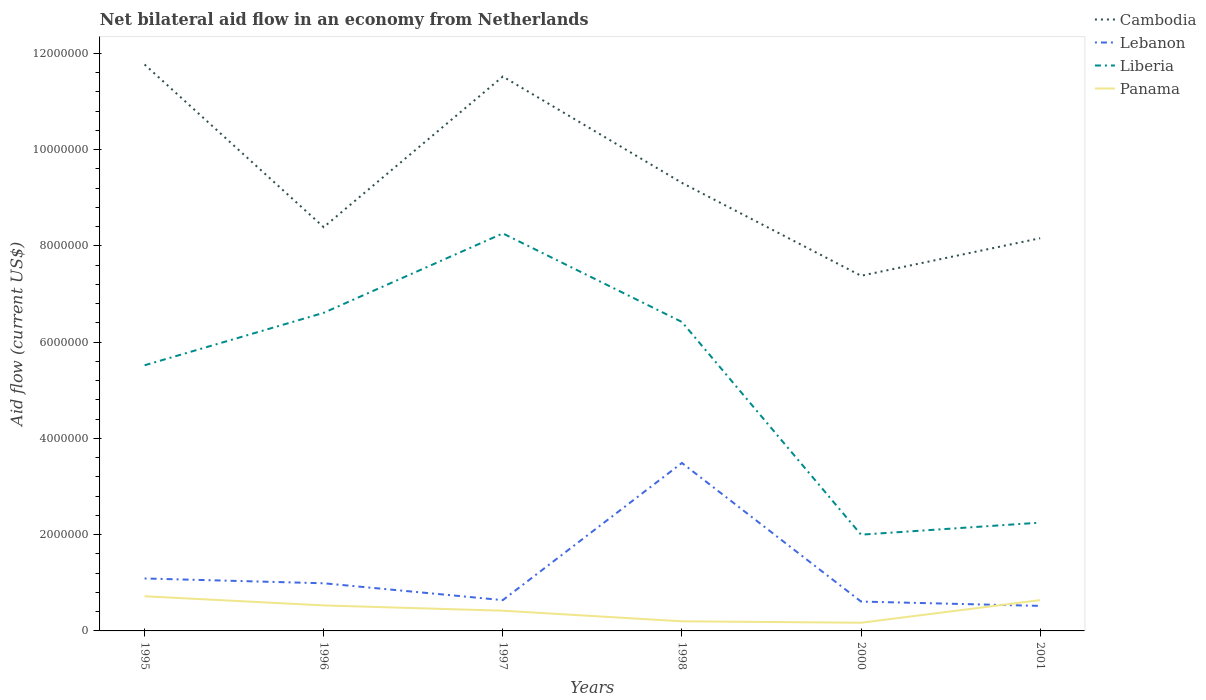How many different coloured lines are there?
Your answer should be very brief. 4. Is the number of lines equal to the number of legend labels?
Your response must be concise. Yes. Across all years, what is the maximum net bilateral aid flow in Cambodia?
Make the answer very short. 7.38e+06. In which year was the net bilateral aid flow in Panama maximum?
Your answer should be very brief. 2000. What is the total net bilateral aid flow in Cambodia in the graph?
Offer a terse response. 4.14e+06. How many years are there in the graph?
Offer a terse response. 6. Does the graph contain grids?
Offer a terse response. No. How many legend labels are there?
Your answer should be very brief. 4. What is the title of the graph?
Your answer should be compact. Net bilateral aid flow in an economy from Netherlands. Does "Maldives" appear as one of the legend labels in the graph?
Make the answer very short. No. What is the Aid flow (current US$) in Cambodia in 1995?
Your answer should be very brief. 1.18e+07. What is the Aid flow (current US$) of Lebanon in 1995?
Provide a succinct answer. 1.09e+06. What is the Aid flow (current US$) in Liberia in 1995?
Your response must be concise. 5.52e+06. What is the Aid flow (current US$) in Panama in 1995?
Keep it short and to the point. 7.20e+05. What is the Aid flow (current US$) in Cambodia in 1996?
Give a very brief answer. 8.39e+06. What is the Aid flow (current US$) of Lebanon in 1996?
Your response must be concise. 9.90e+05. What is the Aid flow (current US$) of Liberia in 1996?
Offer a very short reply. 6.61e+06. What is the Aid flow (current US$) of Panama in 1996?
Ensure brevity in your answer.  5.30e+05. What is the Aid flow (current US$) of Cambodia in 1997?
Keep it short and to the point. 1.15e+07. What is the Aid flow (current US$) in Lebanon in 1997?
Give a very brief answer. 6.40e+05. What is the Aid flow (current US$) of Liberia in 1997?
Your response must be concise. 8.26e+06. What is the Aid flow (current US$) of Panama in 1997?
Offer a very short reply. 4.20e+05. What is the Aid flow (current US$) of Cambodia in 1998?
Ensure brevity in your answer.  9.31e+06. What is the Aid flow (current US$) of Lebanon in 1998?
Your answer should be very brief. 3.49e+06. What is the Aid flow (current US$) in Liberia in 1998?
Give a very brief answer. 6.42e+06. What is the Aid flow (current US$) of Panama in 1998?
Your response must be concise. 2.00e+05. What is the Aid flow (current US$) in Cambodia in 2000?
Provide a succinct answer. 7.38e+06. What is the Aid flow (current US$) of Lebanon in 2000?
Your answer should be very brief. 6.10e+05. What is the Aid flow (current US$) of Liberia in 2000?
Ensure brevity in your answer.  2.00e+06. What is the Aid flow (current US$) in Cambodia in 2001?
Your answer should be compact. 8.16e+06. What is the Aid flow (current US$) of Lebanon in 2001?
Make the answer very short. 5.20e+05. What is the Aid flow (current US$) in Liberia in 2001?
Offer a terse response. 2.25e+06. What is the Aid flow (current US$) in Panama in 2001?
Provide a succinct answer. 6.40e+05. Across all years, what is the maximum Aid flow (current US$) of Cambodia?
Provide a succinct answer. 1.18e+07. Across all years, what is the maximum Aid flow (current US$) of Lebanon?
Your response must be concise. 3.49e+06. Across all years, what is the maximum Aid flow (current US$) of Liberia?
Ensure brevity in your answer.  8.26e+06. Across all years, what is the maximum Aid flow (current US$) of Panama?
Provide a succinct answer. 7.20e+05. Across all years, what is the minimum Aid flow (current US$) of Cambodia?
Your answer should be very brief. 7.38e+06. Across all years, what is the minimum Aid flow (current US$) in Lebanon?
Ensure brevity in your answer.  5.20e+05. What is the total Aid flow (current US$) of Cambodia in the graph?
Your response must be concise. 5.65e+07. What is the total Aid flow (current US$) in Lebanon in the graph?
Provide a succinct answer. 7.34e+06. What is the total Aid flow (current US$) of Liberia in the graph?
Offer a very short reply. 3.11e+07. What is the total Aid flow (current US$) of Panama in the graph?
Offer a very short reply. 2.68e+06. What is the difference between the Aid flow (current US$) of Cambodia in 1995 and that in 1996?
Ensure brevity in your answer.  3.38e+06. What is the difference between the Aid flow (current US$) in Lebanon in 1995 and that in 1996?
Give a very brief answer. 1.00e+05. What is the difference between the Aid flow (current US$) of Liberia in 1995 and that in 1996?
Your response must be concise. -1.09e+06. What is the difference between the Aid flow (current US$) of Cambodia in 1995 and that in 1997?
Offer a very short reply. 2.50e+05. What is the difference between the Aid flow (current US$) in Lebanon in 1995 and that in 1997?
Your response must be concise. 4.50e+05. What is the difference between the Aid flow (current US$) of Liberia in 1995 and that in 1997?
Offer a very short reply. -2.74e+06. What is the difference between the Aid flow (current US$) in Cambodia in 1995 and that in 1998?
Provide a short and direct response. 2.46e+06. What is the difference between the Aid flow (current US$) in Lebanon in 1995 and that in 1998?
Your response must be concise. -2.40e+06. What is the difference between the Aid flow (current US$) of Liberia in 1995 and that in 1998?
Ensure brevity in your answer.  -9.00e+05. What is the difference between the Aid flow (current US$) of Panama in 1995 and that in 1998?
Offer a very short reply. 5.20e+05. What is the difference between the Aid flow (current US$) of Cambodia in 1995 and that in 2000?
Offer a very short reply. 4.39e+06. What is the difference between the Aid flow (current US$) in Liberia in 1995 and that in 2000?
Your answer should be very brief. 3.52e+06. What is the difference between the Aid flow (current US$) of Cambodia in 1995 and that in 2001?
Give a very brief answer. 3.61e+06. What is the difference between the Aid flow (current US$) of Lebanon in 1995 and that in 2001?
Provide a short and direct response. 5.70e+05. What is the difference between the Aid flow (current US$) in Liberia in 1995 and that in 2001?
Offer a very short reply. 3.27e+06. What is the difference between the Aid flow (current US$) of Cambodia in 1996 and that in 1997?
Give a very brief answer. -3.13e+06. What is the difference between the Aid flow (current US$) in Liberia in 1996 and that in 1997?
Offer a terse response. -1.65e+06. What is the difference between the Aid flow (current US$) in Cambodia in 1996 and that in 1998?
Make the answer very short. -9.20e+05. What is the difference between the Aid flow (current US$) in Lebanon in 1996 and that in 1998?
Give a very brief answer. -2.50e+06. What is the difference between the Aid flow (current US$) in Liberia in 1996 and that in 1998?
Give a very brief answer. 1.90e+05. What is the difference between the Aid flow (current US$) in Cambodia in 1996 and that in 2000?
Provide a short and direct response. 1.01e+06. What is the difference between the Aid flow (current US$) of Liberia in 1996 and that in 2000?
Your response must be concise. 4.61e+06. What is the difference between the Aid flow (current US$) in Panama in 1996 and that in 2000?
Your answer should be compact. 3.60e+05. What is the difference between the Aid flow (current US$) of Liberia in 1996 and that in 2001?
Your answer should be very brief. 4.36e+06. What is the difference between the Aid flow (current US$) in Cambodia in 1997 and that in 1998?
Your answer should be very brief. 2.21e+06. What is the difference between the Aid flow (current US$) in Lebanon in 1997 and that in 1998?
Ensure brevity in your answer.  -2.85e+06. What is the difference between the Aid flow (current US$) in Liberia in 1997 and that in 1998?
Provide a short and direct response. 1.84e+06. What is the difference between the Aid flow (current US$) in Panama in 1997 and that in 1998?
Keep it short and to the point. 2.20e+05. What is the difference between the Aid flow (current US$) of Cambodia in 1997 and that in 2000?
Your response must be concise. 4.14e+06. What is the difference between the Aid flow (current US$) in Lebanon in 1997 and that in 2000?
Your response must be concise. 3.00e+04. What is the difference between the Aid flow (current US$) of Liberia in 1997 and that in 2000?
Keep it short and to the point. 6.26e+06. What is the difference between the Aid flow (current US$) in Panama in 1997 and that in 2000?
Offer a very short reply. 2.50e+05. What is the difference between the Aid flow (current US$) in Cambodia in 1997 and that in 2001?
Your answer should be compact. 3.36e+06. What is the difference between the Aid flow (current US$) of Liberia in 1997 and that in 2001?
Provide a succinct answer. 6.01e+06. What is the difference between the Aid flow (current US$) of Panama in 1997 and that in 2001?
Your response must be concise. -2.20e+05. What is the difference between the Aid flow (current US$) of Cambodia in 1998 and that in 2000?
Your response must be concise. 1.93e+06. What is the difference between the Aid flow (current US$) of Lebanon in 1998 and that in 2000?
Your response must be concise. 2.88e+06. What is the difference between the Aid flow (current US$) of Liberia in 1998 and that in 2000?
Keep it short and to the point. 4.42e+06. What is the difference between the Aid flow (current US$) of Cambodia in 1998 and that in 2001?
Make the answer very short. 1.15e+06. What is the difference between the Aid flow (current US$) of Lebanon in 1998 and that in 2001?
Keep it short and to the point. 2.97e+06. What is the difference between the Aid flow (current US$) in Liberia in 1998 and that in 2001?
Offer a terse response. 4.17e+06. What is the difference between the Aid flow (current US$) in Panama in 1998 and that in 2001?
Give a very brief answer. -4.40e+05. What is the difference between the Aid flow (current US$) of Cambodia in 2000 and that in 2001?
Your response must be concise. -7.80e+05. What is the difference between the Aid flow (current US$) in Lebanon in 2000 and that in 2001?
Your response must be concise. 9.00e+04. What is the difference between the Aid flow (current US$) of Liberia in 2000 and that in 2001?
Ensure brevity in your answer.  -2.50e+05. What is the difference between the Aid flow (current US$) of Panama in 2000 and that in 2001?
Your answer should be very brief. -4.70e+05. What is the difference between the Aid flow (current US$) in Cambodia in 1995 and the Aid flow (current US$) in Lebanon in 1996?
Make the answer very short. 1.08e+07. What is the difference between the Aid flow (current US$) in Cambodia in 1995 and the Aid flow (current US$) in Liberia in 1996?
Provide a short and direct response. 5.16e+06. What is the difference between the Aid flow (current US$) in Cambodia in 1995 and the Aid flow (current US$) in Panama in 1996?
Provide a short and direct response. 1.12e+07. What is the difference between the Aid flow (current US$) of Lebanon in 1995 and the Aid flow (current US$) of Liberia in 1996?
Offer a terse response. -5.52e+06. What is the difference between the Aid flow (current US$) of Lebanon in 1995 and the Aid flow (current US$) of Panama in 1996?
Your answer should be compact. 5.60e+05. What is the difference between the Aid flow (current US$) in Liberia in 1995 and the Aid flow (current US$) in Panama in 1996?
Your answer should be compact. 4.99e+06. What is the difference between the Aid flow (current US$) of Cambodia in 1995 and the Aid flow (current US$) of Lebanon in 1997?
Your response must be concise. 1.11e+07. What is the difference between the Aid flow (current US$) in Cambodia in 1995 and the Aid flow (current US$) in Liberia in 1997?
Provide a succinct answer. 3.51e+06. What is the difference between the Aid flow (current US$) in Cambodia in 1995 and the Aid flow (current US$) in Panama in 1997?
Your response must be concise. 1.14e+07. What is the difference between the Aid flow (current US$) in Lebanon in 1995 and the Aid flow (current US$) in Liberia in 1997?
Keep it short and to the point. -7.17e+06. What is the difference between the Aid flow (current US$) in Lebanon in 1995 and the Aid flow (current US$) in Panama in 1997?
Give a very brief answer. 6.70e+05. What is the difference between the Aid flow (current US$) in Liberia in 1995 and the Aid flow (current US$) in Panama in 1997?
Your answer should be compact. 5.10e+06. What is the difference between the Aid flow (current US$) in Cambodia in 1995 and the Aid flow (current US$) in Lebanon in 1998?
Your response must be concise. 8.28e+06. What is the difference between the Aid flow (current US$) of Cambodia in 1995 and the Aid flow (current US$) of Liberia in 1998?
Offer a terse response. 5.35e+06. What is the difference between the Aid flow (current US$) in Cambodia in 1995 and the Aid flow (current US$) in Panama in 1998?
Give a very brief answer. 1.16e+07. What is the difference between the Aid flow (current US$) of Lebanon in 1995 and the Aid flow (current US$) of Liberia in 1998?
Give a very brief answer. -5.33e+06. What is the difference between the Aid flow (current US$) in Lebanon in 1995 and the Aid flow (current US$) in Panama in 1998?
Provide a succinct answer. 8.90e+05. What is the difference between the Aid flow (current US$) of Liberia in 1995 and the Aid flow (current US$) of Panama in 1998?
Make the answer very short. 5.32e+06. What is the difference between the Aid flow (current US$) in Cambodia in 1995 and the Aid flow (current US$) in Lebanon in 2000?
Make the answer very short. 1.12e+07. What is the difference between the Aid flow (current US$) of Cambodia in 1995 and the Aid flow (current US$) of Liberia in 2000?
Keep it short and to the point. 9.77e+06. What is the difference between the Aid flow (current US$) of Cambodia in 1995 and the Aid flow (current US$) of Panama in 2000?
Offer a terse response. 1.16e+07. What is the difference between the Aid flow (current US$) in Lebanon in 1995 and the Aid flow (current US$) in Liberia in 2000?
Keep it short and to the point. -9.10e+05. What is the difference between the Aid flow (current US$) in Lebanon in 1995 and the Aid flow (current US$) in Panama in 2000?
Your answer should be compact. 9.20e+05. What is the difference between the Aid flow (current US$) of Liberia in 1995 and the Aid flow (current US$) of Panama in 2000?
Your answer should be compact. 5.35e+06. What is the difference between the Aid flow (current US$) of Cambodia in 1995 and the Aid flow (current US$) of Lebanon in 2001?
Offer a very short reply. 1.12e+07. What is the difference between the Aid flow (current US$) in Cambodia in 1995 and the Aid flow (current US$) in Liberia in 2001?
Give a very brief answer. 9.52e+06. What is the difference between the Aid flow (current US$) in Cambodia in 1995 and the Aid flow (current US$) in Panama in 2001?
Ensure brevity in your answer.  1.11e+07. What is the difference between the Aid flow (current US$) in Lebanon in 1995 and the Aid flow (current US$) in Liberia in 2001?
Offer a very short reply. -1.16e+06. What is the difference between the Aid flow (current US$) in Lebanon in 1995 and the Aid flow (current US$) in Panama in 2001?
Make the answer very short. 4.50e+05. What is the difference between the Aid flow (current US$) of Liberia in 1995 and the Aid flow (current US$) of Panama in 2001?
Your answer should be very brief. 4.88e+06. What is the difference between the Aid flow (current US$) of Cambodia in 1996 and the Aid flow (current US$) of Lebanon in 1997?
Give a very brief answer. 7.75e+06. What is the difference between the Aid flow (current US$) in Cambodia in 1996 and the Aid flow (current US$) in Panama in 1997?
Provide a succinct answer. 7.97e+06. What is the difference between the Aid flow (current US$) in Lebanon in 1996 and the Aid flow (current US$) in Liberia in 1997?
Your response must be concise. -7.27e+06. What is the difference between the Aid flow (current US$) of Lebanon in 1996 and the Aid flow (current US$) of Panama in 1997?
Offer a very short reply. 5.70e+05. What is the difference between the Aid flow (current US$) of Liberia in 1996 and the Aid flow (current US$) of Panama in 1997?
Keep it short and to the point. 6.19e+06. What is the difference between the Aid flow (current US$) of Cambodia in 1996 and the Aid flow (current US$) of Lebanon in 1998?
Keep it short and to the point. 4.90e+06. What is the difference between the Aid flow (current US$) of Cambodia in 1996 and the Aid flow (current US$) of Liberia in 1998?
Provide a short and direct response. 1.97e+06. What is the difference between the Aid flow (current US$) of Cambodia in 1996 and the Aid flow (current US$) of Panama in 1998?
Your response must be concise. 8.19e+06. What is the difference between the Aid flow (current US$) of Lebanon in 1996 and the Aid flow (current US$) of Liberia in 1998?
Your answer should be compact. -5.43e+06. What is the difference between the Aid flow (current US$) of Lebanon in 1996 and the Aid flow (current US$) of Panama in 1998?
Keep it short and to the point. 7.90e+05. What is the difference between the Aid flow (current US$) in Liberia in 1996 and the Aid flow (current US$) in Panama in 1998?
Give a very brief answer. 6.41e+06. What is the difference between the Aid flow (current US$) in Cambodia in 1996 and the Aid flow (current US$) in Lebanon in 2000?
Give a very brief answer. 7.78e+06. What is the difference between the Aid flow (current US$) in Cambodia in 1996 and the Aid flow (current US$) in Liberia in 2000?
Ensure brevity in your answer.  6.39e+06. What is the difference between the Aid flow (current US$) in Cambodia in 1996 and the Aid flow (current US$) in Panama in 2000?
Your answer should be very brief. 8.22e+06. What is the difference between the Aid flow (current US$) in Lebanon in 1996 and the Aid flow (current US$) in Liberia in 2000?
Offer a very short reply. -1.01e+06. What is the difference between the Aid flow (current US$) in Lebanon in 1996 and the Aid flow (current US$) in Panama in 2000?
Your answer should be very brief. 8.20e+05. What is the difference between the Aid flow (current US$) of Liberia in 1996 and the Aid flow (current US$) of Panama in 2000?
Offer a very short reply. 6.44e+06. What is the difference between the Aid flow (current US$) in Cambodia in 1996 and the Aid flow (current US$) in Lebanon in 2001?
Your response must be concise. 7.87e+06. What is the difference between the Aid flow (current US$) in Cambodia in 1996 and the Aid flow (current US$) in Liberia in 2001?
Provide a succinct answer. 6.14e+06. What is the difference between the Aid flow (current US$) of Cambodia in 1996 and the Aid flow (current US$) of Panama in 2001?
Your answer should be very brief. 7.75e+06. What is the difference between the Aid flow (current US$) of Lebanon in 1996 and the Aid flow (current US$) of Liberia in 2001?
Provide a short and direct response. -1.26e+06. What is the difference between the Aid flow (current US$) of Liberia in 1996 and the Aid flow (current US$) of Panama in 2001?
Keep it short and to the point. 5.97e+06. What is the difference between the Aid flow (current US$) in Cambodia in 1997 and the Aid flow (current US$) in Lebanon in 1998?
Provide a short and direct response. 8.03e+06. What is the difference between the Aid flow (current US$) in Cambodia in 1997 and the Aid flow (current US$) in Liberia in 1998?
Provide a succinct answer. 5.10e+06. What is the difference between the Aid flow (current US$) of Cambodia in 1997 and the Aid flow (current US$) of Panama in 1998?
Give a very brief answer. 1.13e+07. What is the difference between the Aid flow (current US$) in Lebanon in 1997 and the Aid flow (current US$) in Liberia in 1998?
Keep it short and to the point. -5.78e+06. What is the difference between the Aid flow (current US$) of Liberia in 1997 and the Aid flow (current US$) of Panama in 1998?
Your answer should be very brief. 8.06e+06. What is the difference between the Aid flow (current US$) in Cambodia in 1997 and the Aid flow (current US$) in Lebanon in 2000?
Keep it short and to the point. 1.09e+07. What is the difference between the Aid flow (current US$) in Cambodia in 1997 and the Aid flow (current US$) in Liberia in 2000?
Keep it short and to the point. 9.52e+06. What is the difference between the Aid flow (current US$) in Cambodia in 1997 and the Aid flow (current US$) in Panama in 2000?
Provide a succinct answer. 1.14e+07. What is the difference between the Aid flow (current US$) in Lebanon in 1997 and the Aid flow (current US$) in Liberia in 2000?
Your answer should be compact. -1.36e+06. What is the difference between the Aid flow (current US$) of Liberia in 1997 and the Aid flow (current US$) of Panama in 2000?
Make the answer very short. 8.09e+06. What is the difference between the Aid flow (current US$) in Cambodia in 1997 and the Aid flow (current US$) in Lebanon in 2001?
Give a very brief answer. 1.10e+07. What is the difference between the Aid flow (current US$) of Cambodia in 1997 and the Aid flow (current US$) of Liberia in 2001?
Your answer should be very brief. 9.27e+06. What is the difference between the Aid flow (current US$) of Cambodia in 1997 and the Aid flow (current US$) of Panama in 2001?
Make the answer very short. 1.09e+07. What is the difference between the Aid flow (current US$) of Lebanon in 1997 and the Aid flow (current US$) of Liberia in 2001?
Give a very brief answer. -1.61e+06. What is the difference between the Aid flow (current US$) in Liberia in 1997 and the Aid flow (current US$) in Panama in 2001?
Provide a short and direct response. 7.62e+06. What is the difference between the Aid flow (current US$) of Cambodia in 1998 and the Aid flow (current US$) of Lebanon in 2000?
Ensure brevity in your answer.  8.70e+06. What is the difference between the Aid flow (current US$) in Cambodia in 1998 and the Aid flow (current US$) in Liberia in 2000?
Offer a terse response. 7.31e+06. What is the difference between the Aid flow (current US$) in Cambodia in 1998 and the Aid flow (current US$) in Panama in 2000?
Provide a succinct answer. 9.14e+06. What is the difference between the Aid flow (current US$) of Lebanon in 1998 and the Aid flow (current US$) of Liberia in 2000?
Provide a succinct answer. 1.49e+06. What is the difference between the Aid flow (current US$) in Lebanon in 1998 and the Aid flow (current US$) in Panama in 2000?
Your response must be concise. 3.32e+06. What is the difference between the Aid flow (current US$) in Liberia in 1998 and the Aid flow (current US$) in Panama in 2000?
Provide a short and direct response. 6.25e+06. What is the difference between the Aid flow (current US$) in Cambodia in 1998 and the Aid flow (current US$) in Lebanon in 2001?
Provide a succinct answer. 8.79e+06. What is the difference between the Aid flow (current US$) in Cambodia in 1998 and the Aid flow (current US$) in Liberia in 2001?
Ensure brevity in your answer.  7.06e+06. What is the difference between the Aid flow (current US$) in Cambodia in 1998 and the Aid flow (current US$) in Panama in 2001?
Ensure brevity in your answer.  8.67e+06. What is the difference between the Aid flow (current US$) of Lebanon in 1998 and the Aid flow (current US$) of Liberia in 2001?
Ensure brevity in your answer.  1.24e+06. What is the difference between the Aid flow (current US$) in Lebanon in 1998 and the Aid flow (current US$) in Panama in 2001?
Give a very brief answer. 2.85e+06. What is the difference between the Aid flow (current US$) in Liberia in 1998 and the Aid flow (current US$) in Panama in 2001?
Your answer should be compact. 5.78e+06. What is the difference between the Aid flow (current US$) of Cambodia in 2000 and the Aid flow (current US$) of Lebanon in 2001?
Offer a terse response. 6.86e+06. What is the difference between the Aid flow (current US$) in Cambodia in 2000 and the Aid flow (current US$) in Liberia in 2001?
Your answer should be compact. 5.13e+06. What is the difference between the Aid flow (current US$) in Cambodia in 2000 and the Aid flow (current US$) in Panama in 2001?
Offer a terse response. 6.74e+06. What is the difference between the Aid flow (current US$) of Lebanon in 2000 and the Aid flow (current US$) of Liberia in 2001?
Give a very brief answer. -1.64e+06. What is the difference between the Aid flow (current US$) in Lebanon in 2000 and the Aid flow (current US$) in Panama in 2001?
Ensure brevity in your answer.  -3.00e+04. What is the difference between the Aid flow (current US$) in Liberia in 2000 and the Aid flow (current US$) in Panama in 2001?
Ensure brevity in your answer.  1.36e+06. What is the average Aid flow (current US$) of Cambodia per year?
Keep it short and to the point. 9.42e+06. What is the average Aid flow (current US$) in Lebanon per year?
Provide a succinct answer. 1.22e+06. What is the average Aid flow (current US$) in Liberia per year?
Provide a succinct answer. 5.18e+06. What is the average Aid flow (current US$) of Panama per year?
Provide a short and direct response. 4.47e+05. In the year 1995, what is the difference between the Aid flow (current US$) of Cambodia and Aid flow (current US$) of Lebanon?
Keep it short and to the point. 1.07e+07. In the year 1995, what is the difference between the Aid flow (current US$) of Cambodia and Aid flow (current US$) of Liberia?
Make the answer very short. 6.25e+06. In the year 1995, what is the difference between the Aid flow (current US$) of Cambodia and Aid flow (current US$) of Panama?
Provide a succinct answer. 1.10e+07. In the year 1995, what is the difference between the Aid flow (current US$) in Lebanon and Aid flow (current US$) in Liberia?
Make the answer very short. -4.43e+06. In the year 1995, what is the difference between the Aid flow (current US$) of Lebanon and Aid flow (current US$) of Panama?
Ensure brevity in your answer.  3.70e+05. In the year 1995, what is the difference between the Aid flow (current US$) in Liberia and Aid flow (current US$) in Panama?
Provide a succinct answer. 4.80e+06. In the year 1996, what is the difference between the Aid flow (current US$) in Cambodia and Aid flow (current US$) in Lebanon?
Your answer should be compact. 7.40e+06. In the year 1996, what is the difference between the Aid flow (current US$) in Cambodia and Aid flow (current US$) in Liberia?
Give a very brief answer. 1.78e+06. In the year 1996, what is the difference between the Aid flow (current US$) in Cambodia and Aid flow (current US$) in Panama?
Your response must be concise. 7.86e+06. In the year 1996, what is the difference between the Aid flow (current US$) in Lebanon and Aid flow (current US$) in Liberia?
Offer a terse response. -5.62e+06. In the year 1996, what is the difference between the Aid flow (current US$) in Lebanon and Aid flow (current US$) in Panama?
Provide a succinct answer. 4.60e+05. In the year 1996, what is the difference between the Aid flow (current US$) in Liberia and Aid flow (current US$) in Panama?
Your answer should be compact. 6.08e+06. In the year 1997, what is the difference between the Aid flow (current US$) of Cambodia and Aid flow (current US$) of Lebanon?
Ensure brevity in your answer.  1.09e+07. In the year 1997, what is the difference between the Aid flow (current US$) in Cambodia and Aid flow (current US$) in Liberia?
Offer a very short reply. 3.26e+06. In the year 1997, what is the difference between the Aid flow (current US$) in Cambodia and Aid flow (current US$) in Panama?
Offer a terse response. 1.11e+07. In the year 1997, what is the difference between the Aid flow (current US$) in Lebanon and Aid flow (current US$) in Liberia?
Make the answer very short. -7.62e+06. In the year 1997, what is the difference between the Aid flow (current US$) in Lebanon and Aid flow (current US$) in Panama?
Offer a very short reply. 2.20e+05. In the year 1997, what is the difference between the Aid flow (current US$) of Liberia and Aid flow (current US$) of Panama?
Your answer should be very brief. 7.84e+06. In the year 1998, what is the difference between the Aid flow (current US$) in Cambodia and Aid flow (current US$) in Lebanon?
Provide a succinct answer. 5.82e+06. In the year 1998, what is the difference between the Aid flow (current US$) of Cambodia and Aid flow (current US$) of Liberia?
Make the answer very short. 2.89e+06. In the year 1998, what is the difference between the Aid flow (current US$) in Cambodia and Aid flow (current US$) in Panama?
Your response must be concise. 9.11e+06. In the year 1998, what is the difference between the Aid flow (current US$) of Lebanon and Aid flow (current US$) of Liberia?
Your answer should be very brief. -2.93e+06. In the year 1998, what is the difference between the Aid flow (current US$) in Lebanon and Aid flow (current US$) in Panama?
Offer a terse response. 3.29e+06. In the year 1998, what is the difference between the Aid flow (current US$) in Liberia and Aid flow (current US$) in Panama?
Your answer should be very brief. 6.22e+06. In the year 2000, what is the difference between the Aid flow (current US$) in Cambodia and Aid flow (current US$) in Lebanon?
Your answer should be compact. 6.77e+06. In the year 2000, what is the difference between the Aid flow (current US$) in Cambodia and Aid flow (current US$) in Liberia?
Your answer should be very brief. 5.38e+06. In the year 2000, what is the difference between the Aid flow (current US$) in Cambodia and Aid flow (current US$) in Panama?
Your answer should be very brief. 7.21e+06. In the year 2000, what is the difference between the Aid flow (current US$) of Lebanon and Aid flow (current US$) of Liberia?
Offer a terse response. -1.39e+06. In the year 2000, what is the difference between the Aid flow (current US$) of Liberia and Aid flow (current US$) of Panama?
Provide a short and direct response. 1.83e+06. In the year 2001, what is the difference between the Aid flow (current US$) in Cambodia and Aid flow (current US$) in Lebanon?
Offer a very short reply. 7.64e+06. In the year 2001, what is the difference between the Aid flow (current US$) in Cambodia and Aid flow (current US$) in Liberia?
Keep it short and to the point. 5.91e+06. In the year 2001, what is the difference between the Aid flow (current US$) of Cambodia and Aid flow (current US$) of Panama?
Provide a short and direct response. 7.52e+06. In the year 2001, what is the difference between the Aid flow (current US$) in Lebanon and Aid flow (current US$) in Liberia?
Make the answer very short. -1.73e+06. In the year 2001, what is the difference between the Aid flow (current US$) of Liberia and Aid flow (current US$) of Panama?
Offer a terse response. 1.61e+06. What is the ratio of the Aid flow (current US$) in Cambodia in 1995 to that in 1996?
Offer a terse response. 1.4. What is the ratio of the Aid flow (current US$) in Lebanon in 1995 to that in 1996?
Provide a succinct answer. 1.1. What is the ratio of the Aid flow (current US$) in Liberia in 1995 to that in 1996?
Provide a short and direct response. 0.84. What is the ratio of the Aid flow (current US$) in Panama in 1995 to that in 1996?
Provide a succinct answer. 1.36. What is the ratio of the Aid flow (current US$) of Cambodia in 1995 to that in 1997?
Your answer should be compact. 1.02. What is the ratio of the Aid flow (current US$) in Lebanon in 1995 to that in 1997?
Make the answer very short. 1.7. What is the ratio of the Aid flow (current US$) of Liberia in 1995 to that in 1997?
Your response must be concise. 0.67. What is the ratio of the Aid flow (current US$) of Panama in 1995 to that in 1997?
Your response must be concise. 1.71. What is the ratio of the Aid flow (current US$) in Cambodia in 1995 to that in 1998?
Offer a terse response. 1.26. What is the ratio of the Aid flow (current US$) in Lebanon in 1995 to that in 1998?
Your response must be concise. 0.31. What is the ratio of the Aid flow (current US$) of Liberia in 1995 to that in 1998?
Offer a very short reply. 0.86. What is the ratio of the Aid flow (current US$) in Cambodia in 1995 to that in 2000?
Offer a terse response. 1.59. What is the ratio of the Aid flow (current US$) in Lebanon in 1995 to that in 2000?
Your response must be concise. 1.79. What is the ratio of the Aid flow (current US$) in Liberia in 1995 to that in 2000?
Provide a short and direct response. 2.76. What is the ratio of the Aid flow (current US$) in Panama in 1995 to that in 2000?
Offer a very short reply. 4.24. What is the ratio of the Aid flow (current US$) in Cambodia in 1995 to that in 2001?
Your response must be concise. 1.44. What is the ratio of the Aid flow (current US$) in Lebanon in 1995 to that in 2001?
Offer a terse response. 2.1. What is the ratio of the Aid flow (current US$) of Liberia in 1995 to that in 2001?
Keep it short and to the point. 2.45. What is the ratio of the Aid flow (current US$) of Panama in 1995 to that in 2001?
Your answer should be very brief. 1.12. What is the ratio of the Aid flow (current US$) of Cambodia in 1996 to that in 1997?
Keep it short and to the point. 0.73. What is the ratio of the Aid flow (current US$) of Lebanon in 1996 to that in 1997?
Ensure brevity in your answer.  1.55. What is the ratio of the Aid flow (current US$) of Liberia in 1996 to that in 1997?
Keep it short and to the point. 0.8. What is the ratio of the Aid flow (current US$) in Panama in 1996 to that in 1997?
Offer a very short reply. 1.26. What is the ratio of the Aid flow (current US$) in Cambodia in 1996 to that in 1998?
Your answer should be compact. 0.9. What is the ratio of the Aid flow (current US$) in Lebanon in 1996 to that in 1998?
Make the answer very short. 0.28. What is the ratio of the Aid flow (current US$) in Liberia in 1996 to that in 1998?
Make the answer very short. 1.03. What is the ratio of the Aid flow (current US$) of Panama in 1996 to that in 1998?
Provide a short and direct response. 2.65. What is the ratio of the Aid flow (current US$) of Cambodia in 1996 to that in 2000?
Keep it short and to the point. 1.14. What is the ratio of the Aid flow (current US$) of Lebanon in 1996 to that in 2000?
Provide a succinct answer. 1.62. What is the ratio of the Aid flow (current US$) in Liberia in 1996 to that in 2000?
Your answer should be compact. 3.31. What is the ratio of the Aid flow (current US$) in Panama in 1996 to that in 2000?
Give a very brief answer. 3.12. What is the ratio of the Aid flow (current US$) of Cambodia in 1996 to that in 2001?
Give a very brief answer. 1.03. What is the ratio of the Aid flow (current US$) in Lebanon in 1996 to that in 2001?
Provide a succinct answer. 1.9. What is the ratio of the Aid flow (current US$) of Liberia in 1996 to that in 2001?
Your answer should be very brief. 2.94. What is the ratio of the Aid flow (current US$) in Panama in 1996 to that in 2001?
Ensure brevity in your answer.  0.83. What is the ratio of the Aid flow (current US$) in Cambodia in 1997 to that in 1998?
Offer a very short reply. 1.24. What is the ratio of the Aid flow (current US$) in Lebanon in 1997 to that in 1998?
Give a very brief answer. 0.18. What is the ratio of the Aid flow (current US$) of Liberia in 1997 to that in 1998?
Make the answer very short. 1.29. What is the ratio of the Aid flow (current US$) of Cambodia in 1997 to that in 2000?
Offer a terse response. 1.56. What is the ratio of the Aid flow (current US$) of Lebanon in 1997 to that in 2000?
Offer a very short reply. 1.05. What is the ratio of the Aid flow (current US$) in Liberia in 1997 to that in 2000?
Provide a succinct answer. 4.13. What is the ratio of the Aid flow (current US$) of Panama in 1997 to that in 2000?
Provide a short and direct response. 2.47. What is the ratio of the Aid flow (current US$) in Cambodia in 1997 to that in 2001?
Your response must be concise. 1.41. What is the ratio of the Aid flow (current US$) in Lebanon in 1997 to that in 2001?
Offer a terse response. 1.23. What is the ratio of the Aid flow (current US$) in Liberia in 1997 to that in 2001?
Make the answer very short. 3.67. What is the ratio of the Aid flow (current US$) of Panama in 1997 to that in 2001?
Make the answer very short. 0.66. What is the ratio of the Aid flow (current US$) of Cambodia in 1998 to that in 2000?
Keep it short and to the point. 1.26. What is the ratio of the Aid flow (current US$) of Lebanon in 1998 to that in 2000?
Give a very brief answer. 5.72. What is the ratio of the Aid flow (current US$) of Liberia in 1998 to that in 2000?
Provide a short and direct response. 3.21. What is the ratio of the Aid flow (current US$) in Panama in 1998 to that in 2000?
Keep it short and to the point. 1.18. What is the ratio of the Aid flow (current US$) in Cambodia in 1998 to that in 2001?
Provide a succinct answer. 1.14. What is the ratio of the Aid flow (current US$) of Lebanon in 1998 to that in 2001?
Make the answer very short. 6.71. What is the ratio of the Aid flow (current US$) in Liberia in 1998 to that in 2001?
Give a very brief answer. 2.85. What is the ratio of the Aid flow (current US$) in Panama in 1998 to that in 2001?
Your answer should be very brief. 0.31. What is the ratio of the Aid flow (current US$) of Cambodia in 2000 to that in 2001?
Offer a very short reply. 0.9. What is the ratio of the Aid flow (current US$) in Lebanon in 2000 to that in 2001?
Give a very brief answer. 1.17. What is the ratio of the Aid flow (current US$) in Panama in 2000 to that in 2001?
Make the answer very short. 0.27. What is the difference between the highest and the second highest Aid flow (current US$) in Lebanon?
Your answer should be very brief. 2.40e+06. What is the difference between the highest and the second highest Aid flow (current US$) in Liberia?
Keep it short and to the point. 1.65e+06. What is the difference between the highest and the second highest Aid flow (current US$) in Panama?
Make the answer very short. 8.00e+04. What is the difference between the highest and the lowest Aid flow (current US$) in Cambodia?
Provide a short and direct response. 4.39e+06. What is the difference between the highest and the lowest Aid flow (current US$) in Lebanon?
Keep it short and to the point. 2.97e+06. What is the difference between the highest and the lowest Aid flow (current US$) of Liberia?
Ensure brevity in your answer.  6.26e+06. What is the difference between the highest and the lowest Aid flow (current US$) of Panama?
Keep it short and to the point. 5.50e+05. 